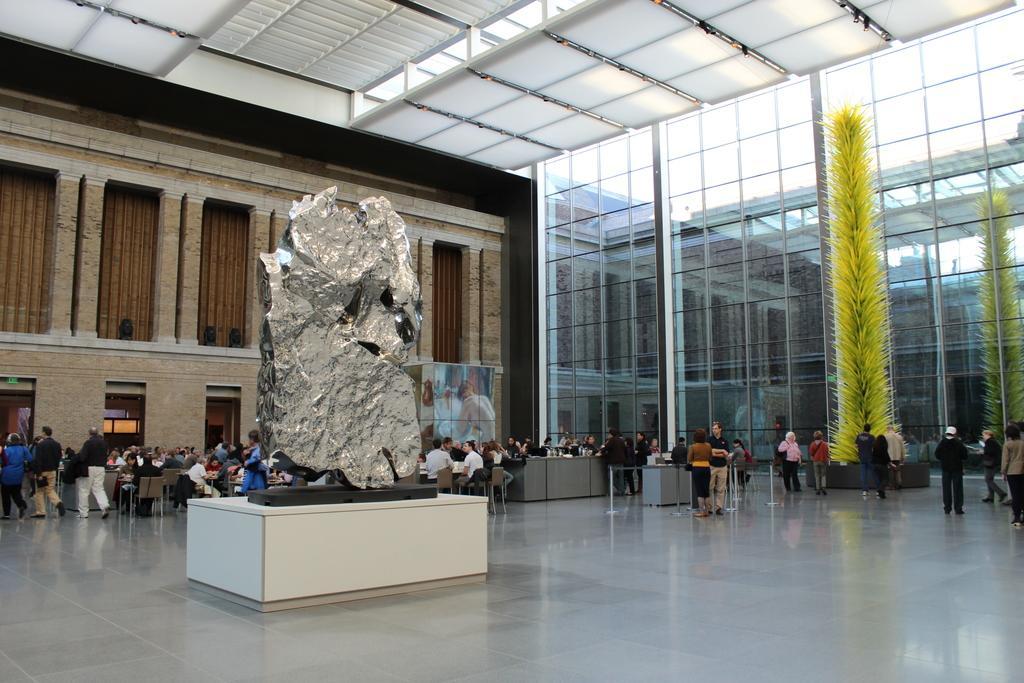In one or two sentences, can you explain what this image depicts? In the picture we can see a stone sculpture which is placed on the white color stone plank in the building area on the floor and in the background, we can see a wall with stone pillars and doors near it, we can see some people standing near the desks and some people are walking and on the other side of the wall we can see a glass wall and near it also we can see some people are standing. 